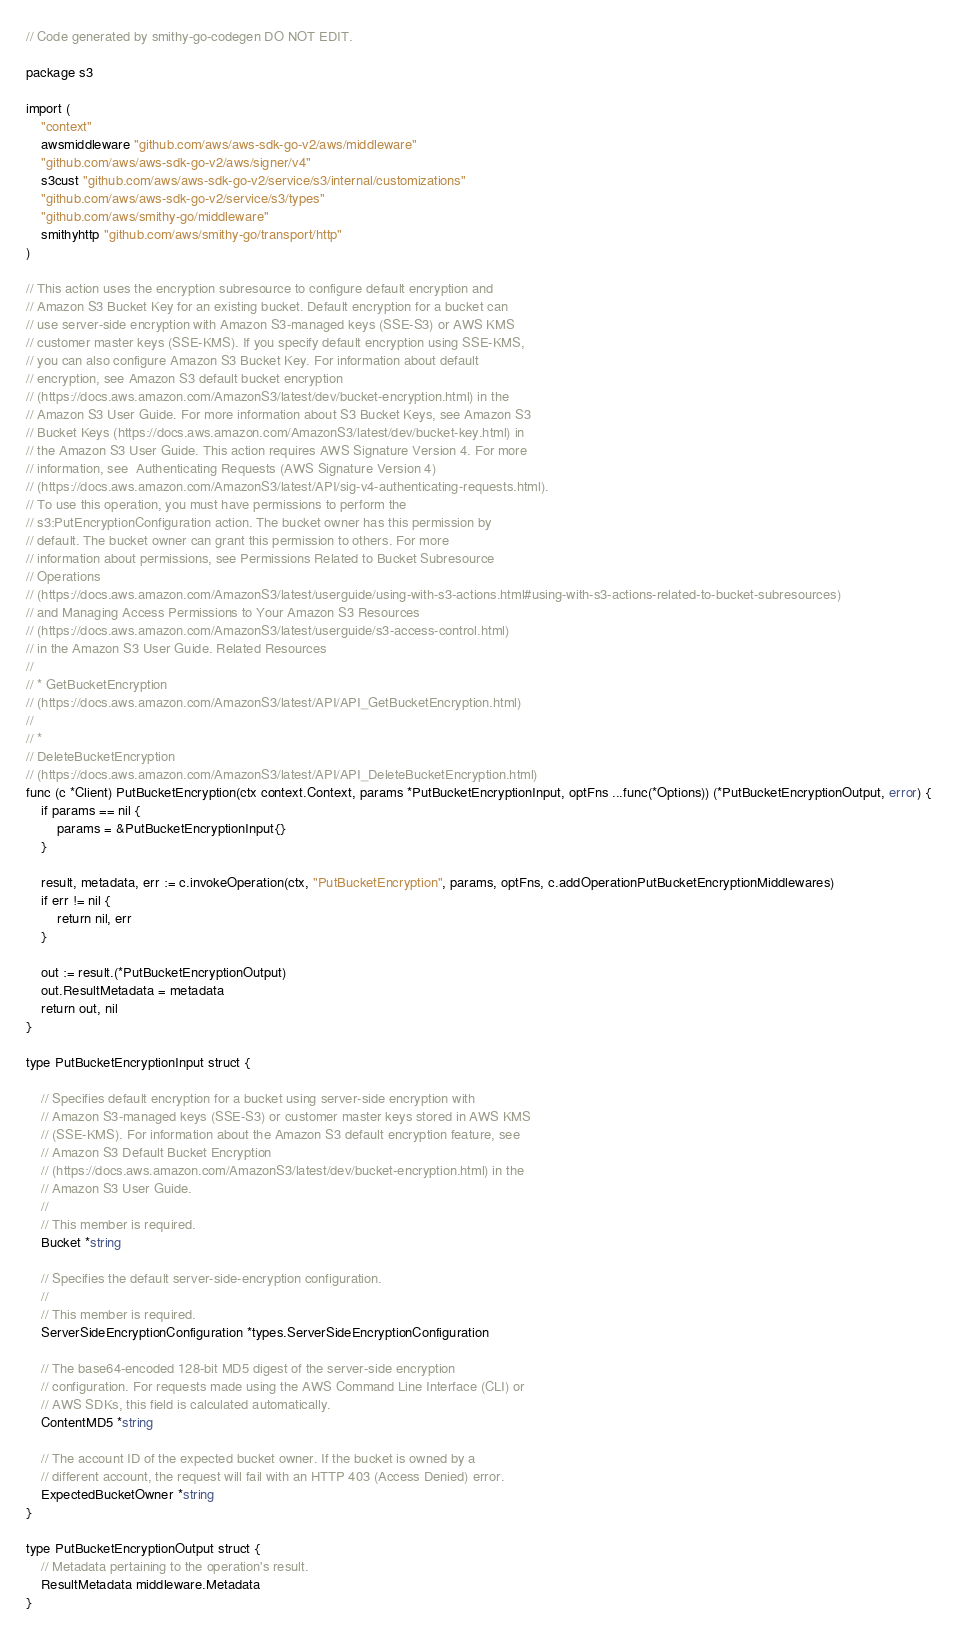<code> <loc_0><loc_0><loc_500><loc_500><_Go_>// Code generated by smithy-go-codegen DO NOT EDIT.

package s3

import (
	"context"
	awsmiddleware "github.com/aws/aws-sdk-go-v2/aws/middleware"
	"github.com/aws/aws-sdk-go-v2/aws/signer/v4"
	s3cust "github.com/aws/aws-sdk-go-v2/service/s3/internal/customizations"
	"github.com/aws/aws-sdk-go-v2/service/s3/types"
	"github.com/aws/smithy-go/middleware"
	smithyhttp "github.com/aws/smithy-go/transport/http"
)

// This action uses the encryption subresource to configure default encryption and
// Amazon S3 Bucket Key for an existing bucket. Default encryption for a bucket can
// use server-side encryption with Amazon S3-managed keys (SSE-S3) or AWS KMS
// customer master keys (SSE-KMS). If you specify default encryption using SSE-KMS,
// you can also configure Amazon S3 Bucket Key. For information about default
// encryption, see Amazon S3 default bucket encryption
// (https://docs.aws.amazon.com/AmazonS3/latest/dev/bucket-encryption.html) in the
// Amazon S3 User Guide. For more information about S3 Bucket Keys, see Amazon S3
// Bucket Keys (https://docs.aws.amazon.com/AmazonS3/latest/dev/bucket-key.html) in
// the Amazon S3 User Guide. This action requires AWS Signature Version 4. For more
// information, see  Authenticating Requests (AWS Signature Version 4)
// (https://docs.aws.amazon.com/AmazonS3/latest/API/sig-v4-authenticating-requests.html).
// To use this operation, you must have permissions to perform the
// s3:PutEncryptionConfiguration action. The bucket owner has this permission by
// default. The bucket owner can grant this permission to others. For more
// information about permissions, see Permissions Related to Bucket Subresource
// Operations
// (https://docs.aws.amazon.com/AmazonS3/latest/userguide/using-with-s3-actions.html#using-with-s3-actions-related-to-bucket-subresources)
// and Managing Access Permissions to Your Amazon S3 Resources
// (https://docs.aws.amazon.com/AmazonS3/latest/userguide/s3-access-control.html)
// in the Amazon S3 User Guide. Related Resources
//
// * GetBucketEncryption
// (https://docs.aws.amazon.com/AmazonS3/latest/API/API_GetBucketEncryption.html)
//
// *
// DeleteBucketEncryption
// (https://docs.aws.amazon.com/AmazonS3/latest/API/API_DeleteBucketEncryption.html)
func (c *Client) PutBucketEncryption(ctx context.Context, params *PutBucketEncryptionInput, optFns ...func(*Options)) (*PutBucketEncryptionOutput, error) {
	if params == nil {
		params = &PutBucketEncryptionInput{}
	}

	result, metadata, err := c.invokeOperation(ctx, "PutBucketEncryption", params, optFns, c.addOperationPutBucketEncryptionMiddlewares)
	if err != nil {
		return nil, err
	}

	out := result.(*PutBucketEncryptionOutput)
	out.ResultMetadata = metadata
	return out, nil
}

type PutBucketEncryptionInput struct {

	// Specifies default encryption for a bucket using server-side encryption with
	// Amazon S3-managed keys (SSE-S3) or customer master keys stored in AWS KMS
	// (SSE-KMS). For information about the Amazon S3 default encryption feature, see
	// Amazon S3 Default Bucket Encryption
	// (https://docs.aws.amazon.com/AmazonS3/latest/dev/bucket-encryption.html) in the
	// Amazon S3 User Guide.
	//
	// This member is required.
	Bucket *string

	// Specifies the default server-side-encryption configuration.
	//
	// This member is required.
	ServerSideEncryptionConfiguration *types.ServerSideEncryptionConfiguration

	// The base64-encoded 128-bit MD5 digest of the server-side encryption
	// configuration. For requests made using the AWS Command Line Interface (CLI) or
	// AWS SDKs, this field is calculated automatically.
	ContentMD5 *string

	// The account ID of the expected bucket owner. If the bucket is owned by a
	// different account, the request will fail with an HTTP 403 (Access Denied) error.
	ExpectedBucketOwner *string
}

type PutBucketEncryptionOutput struct {
	// Metadata pertaining to the operation's result.
	ResultMetadata middleware.Metadata
}
</code> 